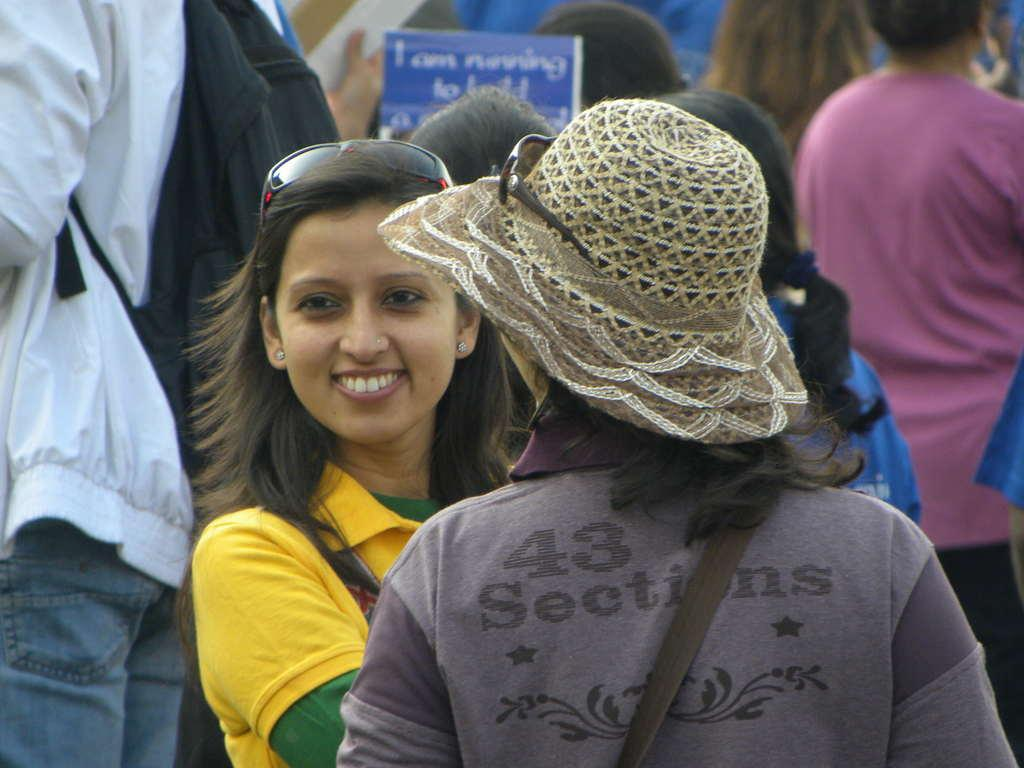What is the main subject of the image? The main subject of the image is a group of people. Can you describe one person in the group? There is a woman with a yellow t-shirt in the image. What is the woman doing in the image? The woman is standing and smiling. What else can be seen in the image besides the people? There is a board with text in the image. What verse is being recited by the group in the image? There is no indication in the image that the group is reciting a verse, so it cannot be determined from the picture. 